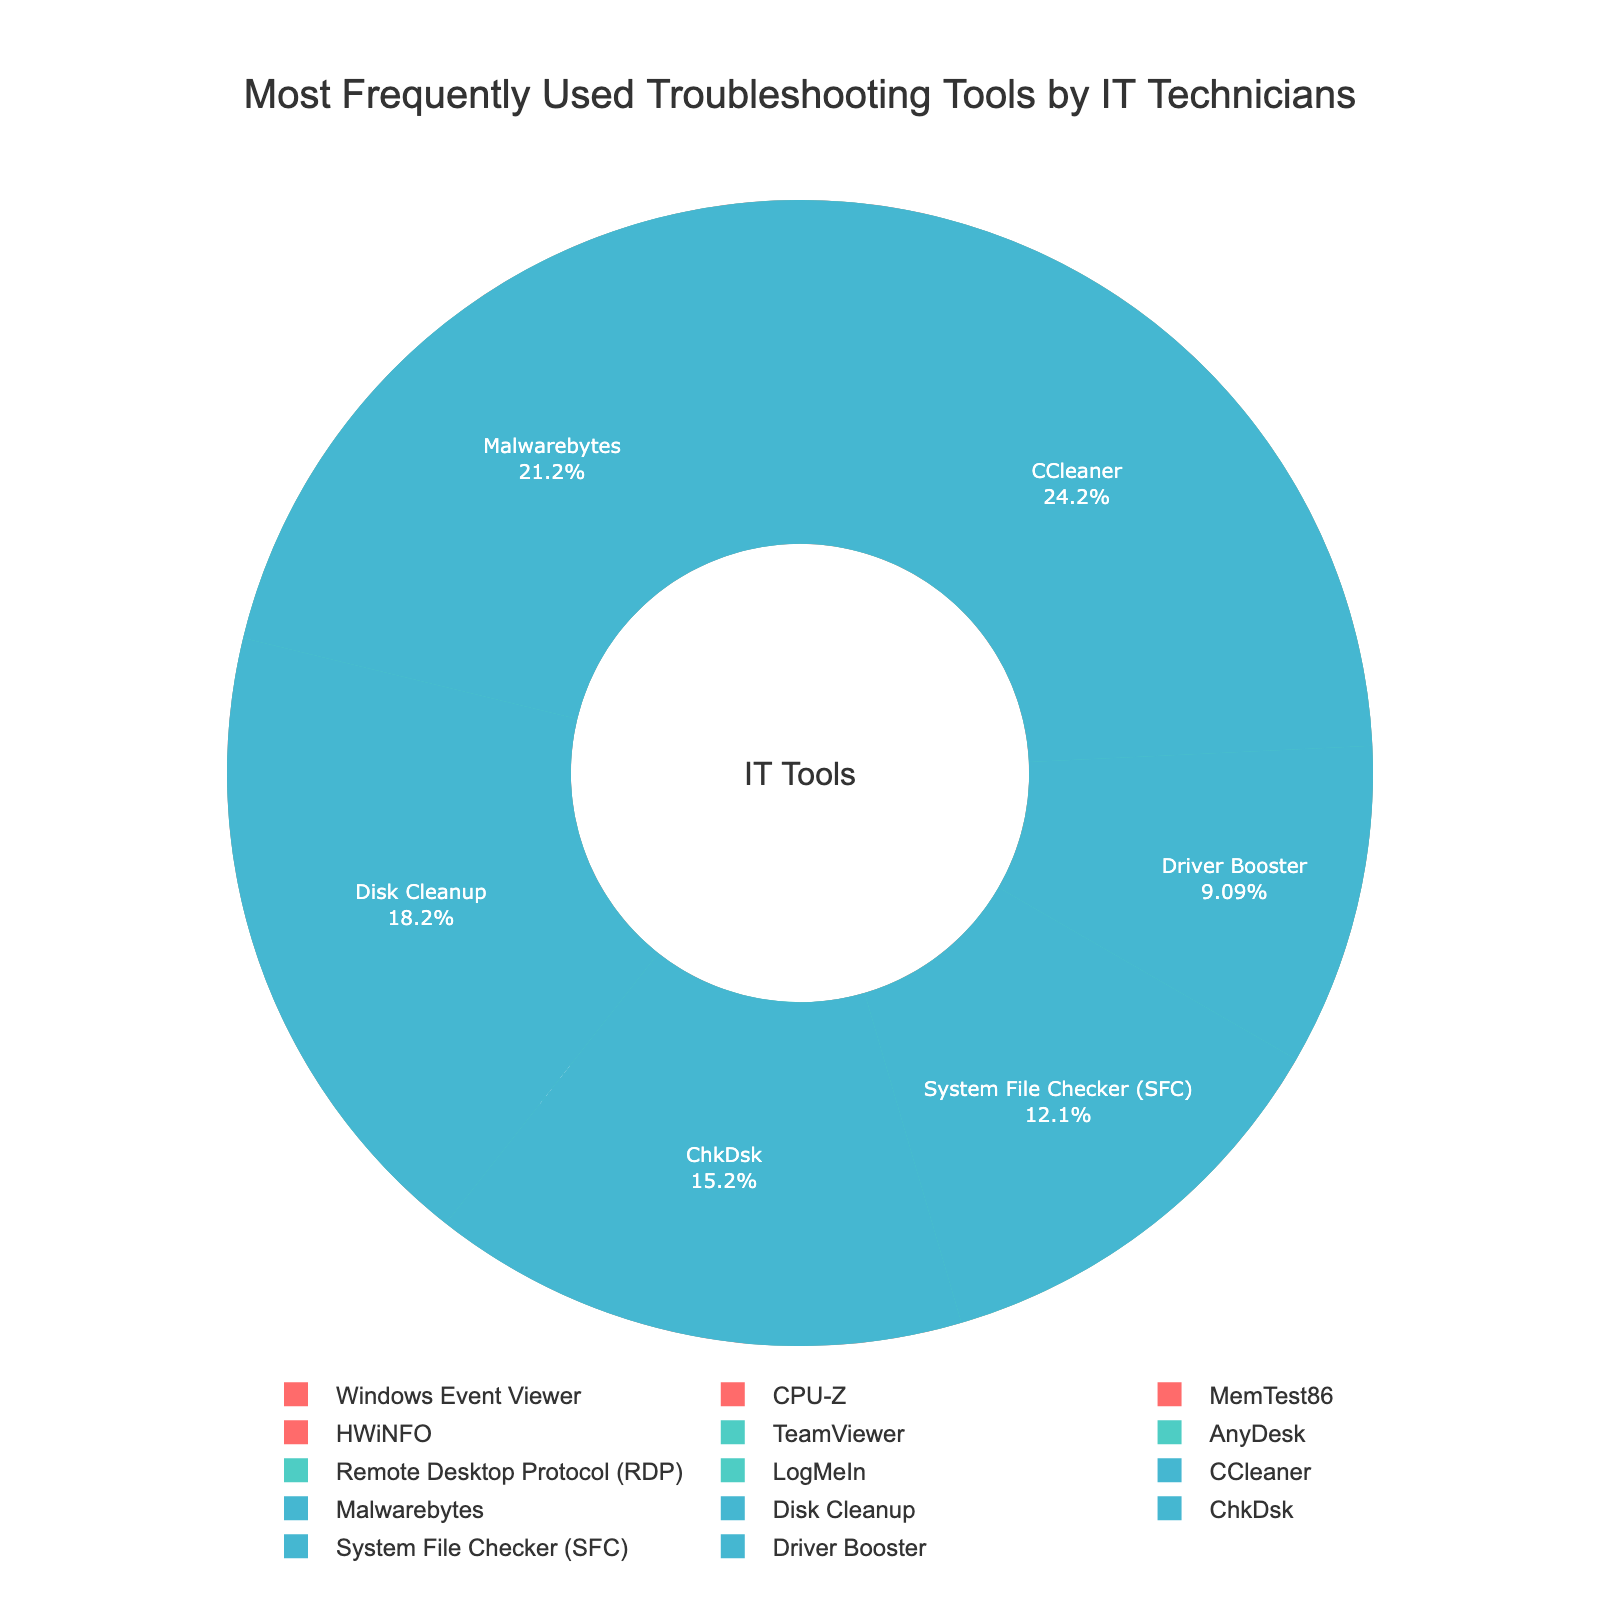What is the most frequently used diagnostic tool? By looking at the pie section labeled "15%", we see that it corresponds to "Windows Event Viewer," which is the largest slice in the Diagnostic category.
Answer: Windows Event Viewer Which category has the tool with the highest percentage usage? By comparing the largest slices of each category, "Windows Event Viewer" (Diagnostic) with 15%, "TeamViewer" (Remote Access) with 12%, and "CCleaner" (System Repair) with 8%, Diagnostic has the highest percentage.
Answer: Diagnostic If we combined the usage percentages of "CCleaner" and "Malwarebytes," would they exceed "Windows Event Viewer"? CCleaner (8%) + Malwarebytes (7%) = 15%, which exactly matches the percentage of Windows Event Viewer, hence they do not exceed.
Answer: No Which Remote Access tool is used exactly as frequently as "MemTest86"? Referring to the pie sections labeled with percentage values, we find that both "MemTest86" and "Remote Desktop Protocol (RDP)" are represented by 7%.
Answer: Remote Desktop Protocol (RDP) Compare the total percentage of all System Repair tools to all Remote Access tools. Adding System Repair tools' percentages (8% + 7% + 6% + 5% + 4% + 3% = 33%) and Remote Access tools' percentages (12% + 9% + 7% + 4% = 32%), System Repair has a higher total percentage.
Answer: System Repair Which category has the fewest tools, and how many are there? By counting slices in each category: Diagnostic (4 tools), Remote Access (4 tools), and System Repair (6 tools), we observe that Diagnostic and Remote Access both have the fewest number of tools.
Answer: Diagnostic and Remote Access, 4 tools each What is the combined percentage of the least frequently used tools in each category? The least frequently used tools are "HWiNFO" (5%) in Diagnostic, "LogMeIn" (4%) in Remote Access, and "Driver Booster" (3%) in System Repair. Their combined percentage is 5% + 4% + 3% = 12%.
Answer: 12% Among all categories, which tool has the smallest percentage? By visually identifying the smallest slice, we find "Driver Booster" in System Repair, which has a percentage of 3%.
Answer: Driver Booster What is the total percentage of the two most frequently used tools? The most frequently used tools are "Windows Event Viewer" (15%) and "TeamViewer" (12%). Their total percentage is 15% + 12% = 27%.
Answer: 27% Is the usage percentage of "AnyDesk" greater than the sum of "ChkDsk" and "System File Checker (SFC)"? AnyDesk has 9%, while ChkDsk (5%) + System File Checker (4%) = 9%, which equals AnyDesk's percentage but does not exceed it.
Answer: No 